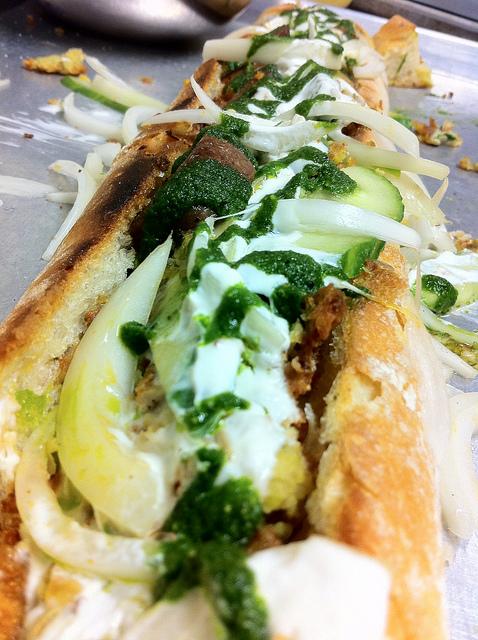Should this be eaten with a fork?
Quick response, please. No. What is inside of this sandwich?
Short answer required. Vegetables. Did Subway make this?
Quick response, please. No. Is this a sandwich for one?
Short answer required. No. 